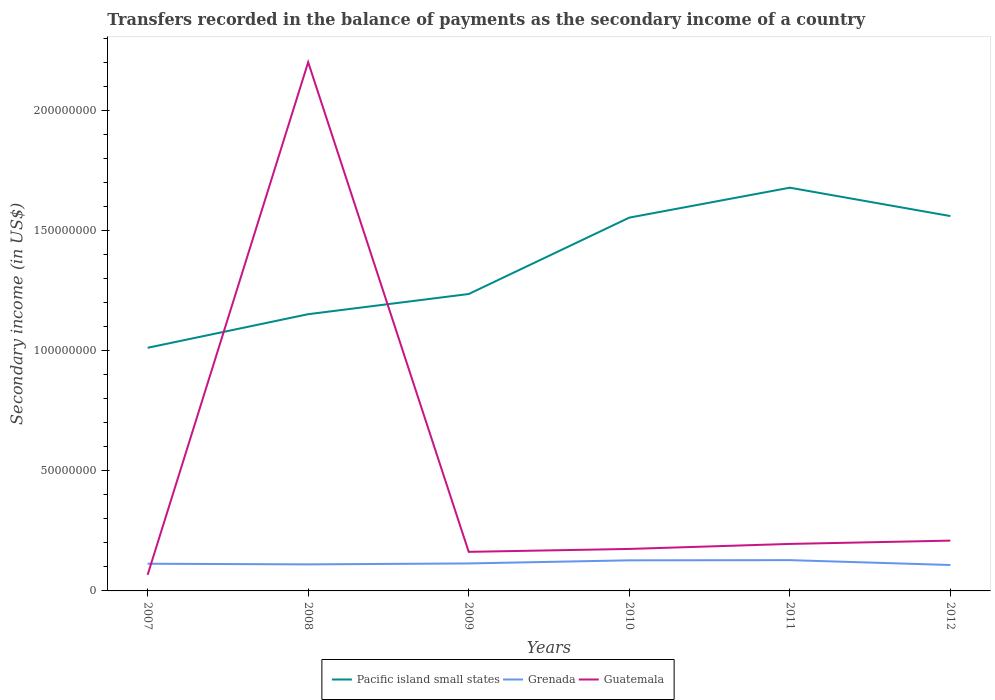How many different coloured lines are there?
Your answer should be very brief. 3. Does the line corresponding to Guatemala intersect with the line corresponding to Grenada?
Give a very brief answer. Yes. Is the number of lines equal to the number of legend labels?
Your response must be concise. Yes. Across all years, what is the maximum secondary income of in Guatemala?
Your answer should be very brief. 6.70e+06. In which year was the secondary income of in Guatemala maximum?
Your response must be concise. 2007. What is the total secondary income of in Guatemala in the graph?
Provide a short and direct response. -3.30e+06. What is the difference between the highest and the second highest secondary income of in Pacific island small states?
Your response must be concise. 6.67e+07. Is the secondary income of in Guatemala strictly greater than the secondary income of in Grenada over the years?
Ensure brevity in your answer.  No. How many lines are there?
Give a very brief answer. 3. What is the difference between two consecutive major ticks on the Y-axis?
Your answer should be compact. 5.00e+07. Are the values on the major ticks of Y-axis written in scientific E-notation?
Provide a short and direct response. No. Does the graph contain grids?
Your response must be concise. No. How many legend labels are there?
Your answer should be very brief. 3. How are the legend labels stacked?
Offer a very short reply. Horizontal. What is the title of the graph?
Your answer should be compact. Transfers recorded in the balance of payments as the secondary income of a country. Does "Indonesia" appear as one of the legend labels in the graph?
Give a very brief answer. No. What is the label or title of the X-axis?
Provide a succinct answer. Years. What is the label or title of the Y-axis?
Ensure brevity in your answer.  Secondary income (in US$). What is the Secondary income (in US$) of Pacific island small states in 2007?
Make the answer very short. 1.01e+08. What is the Secondary income (in US$) in Grenada in 2007?
Ensure brevity in your answer.  1.13e+07. What is the Secondary income (in US$) of Guatemala in 2007?
Offer a terse response. 6.70e+06. What is the Secondary income (in US$) in Pacific island small states in 2008?
Ensure brevity in your answer.  1.15e+08. What is the Secondary income (in US$) of Grenada in 2008?
Offer a terse response. 1.11e+07. What is the Secondary income (in US$) of Guatemala in 2008?
Give a very brief answer. 2.20e+08. What is the Secondary income (in US$) in Pacific island small states in 2009?
Make the answer very short. 1.24e+08. What is the Secondary income (in US$) in Grenada in 2009?
Your response must be concise. 1.14e+07. What is the Secondary income (in US$) in Guatemala in 2009?
Your answer should be very brief. 1.63e+07. What is the Secondary income (in US$) in Pacific island small states in 2010?
Provide a short and direct response. 1.55e+08. What is the Secondary income (in US$) in Grenada in 2010?
Give a very brief answer. 1.27e+07. What is the Secondary income (in US$) in Guatemala in 2010?
Provide a short and direct response. 1.75e+07. What is the Secondary income (in US$) of Pacific island small states in 2011?
Offer a very short reply. 1.68e+08. What is the Secondary income (in US$) in Grenada in 2011?
Provide a short and direct response. 1.28e+07. What is the Secondary income (in US$) in Guatemala in 2011?
Offer a terse response. 1.96e+07. What is the Secondary income (in US$) of Pacific island small states in 2012?
Provide a short and direct response. 1.56e+08. What is the Secondary income (in US$) in Grenada in 2012?
Keep it short and to the point. 1.08e+07. What is the Secondary income (in US$) of Guatemala in 2012?
Make the answer very short. 2.09e+07. Across all years, what is the maximum Secondary income (in US$) of Pacific island small states?
Offer a very short reply. 1.68e+08. Across all years, what is the maximum Secondary income (in US$) of Grenada?
Give a very brief answer. 1.28e+07. Across all years, what is the maximum Secondary income (in US$) in Guatemala?
Your answer should be compact. 2.20e+08. Across all years, what is the minimum Secondary income (in US$) in Pacific island small states?
Provide a succinct answer. 1.01e+08. Across all years, what is the minimum Secondary income (in US$) in Grenada?
Provide a short and direct response. 1.08e+07. Across all years, what is the minimum Secondary income (in US$) of Guatemala?
Provide a succinct answer. 6.70e+06. What is the total Secondary income (in US$) in Pacific island small states in the graph?
Your response must be concise. 8.19e+08. What is the total Secondary income (in US$) in Grenada in the graph?
Keep it short and to the point. 7.01e+07. What is the total Secondary income (in US$) of Guatemala in the graph?
Offer a very short reply. 3.01e+08. What is the difference between the Secondary income (in US$) in Pacific island small states in 2007 and that in 2008?
Ensure brevity in your answer.  -1.40e+07. What is the difference between the Secondary income (in US$) of Grenada in 2007 and that in 2008?
Your response must be concise. 2.65e+05. What is the difference between the Secondary income (in US$) of Guatemala in 2007 and that in 2008?
Your response must be concise. -2.13e+08. What is the difference between the Secondary income (in US$) in Pacific island small states in 2007 and that in 2009?
Provide a short and direct response. -2.24e+07. What is the difference between the Secondary income (in US$) in Grenada in 2007 and that in 2009?
Provide a short and direct response. -1.26e+05. What is the difference between the Secondary income (in US$) in Guatemala in 2007 and that in 2009?
Your answer should be very brief. -9.56e+06. What is the difference between the Secondary income (in US$) in Pacific island small states in 2007 and that in 2010?
Ensure brevity in your answer.  -5.42e+07. What is the difference between the Secondary income (in US$) of Grenada in 2007 and that in 2010?
Provide a succinct answer. -1.42e+06. What is the difference between the Secondary income (in US$) of Guatemala in 2007 and that in 2010?
Your answer should be compact. -1.08e+07. What is the difference between the Secondary income (in US$) in Pacific island small states in 2007 and that in 2011?
Offer a very short reply. -6.67e+07. What is the difference between the Secondary income (in US$) in Grenada in 2007 and that in 2011?
Your answer should be compact. -1.49e+06. What is the difference between the Secondary income (in US$) in Guatemala in 2007 and that in 2011?
Your answer should be very brief. -1.29e+07. What is the difference between the Secondary income (in US$) of Pacific island small states in 2007 and that in 2012?
Give a very brief answer. -5.48e+07. What is the difference between the Secondary income (in US$) in Grenada in 2007 and that in 2012?
Provide a short and direct response. 5.26e+05. What is the difference between the Secondary income (in US$) of Guatemala in 2007 and that in 2012?
Ensure brevity in your answer.  -1.42e+07. What is the difference between the Secondary income (in US$) in Pacific island small states in 2008 and that in 2009?
Provide a short and direct response. -8.40e+06. What is the difference between the Secondary income (in US$) of Grenada in 2008 and that in 2009?
Keep it short and to the point. -3.91e+05. What is the difference between the Secondary income (in US$) of Guatemala in 2008 and that in 2009?
Your answer should be very brief. 2.04e+08. What is the difference between the Secondary income (in US$) in Pacific island small states in 2008 and that in 2010?
Your answer should be compact. -4.02e+07. What is the difference between the Secondary income (in US$) in Grenada in 2008 and that in 2010?
Your answer should be compact. -1.68e+06. What is the difference between the Secondary income (in US$) of Guatemala in 2008 and that in 2010?
Provide a short and direct response. 2.03e+08. What is the difference between the Secondary income (in US$) in Pacific island small states in 2008 and that in 2011?
Make the answer very short. -5.27e+07. What is the difference between the Secondary income (in US$) in Grenada in 2008 and that in 2011?
Ensure brevity in your answer.  -1.76e+06. What is the difference between the Secondary income (in US$) of Guatemala in 2008 and that in 2011?
Offer a very short reply. 2.01e+08. What is the difference between the Secondary income (in US$) in Pacific island small states in 2008 and that in 2012?
Make the answer very short. -4.08e+07. What is the difference between the Secondary income (in US$) of Grenada in 2008 and that in 2012?
Provide a succinct answer. 2.61e+05. What is the difference between the Secondary income (in US$) in Guatemala in 2008 and that in 2012?
Ensure brevity in your answer.  1.99e+08. What is the difference between the Secondary income (in US$) of Pacific island small states in 2009 and that in 2010?
Keep it short and to the point. -3.18e+07. What is the difference between the Secondary income (in US$) of Grenada in 2009 and that in 2010?
Your answer should be very brief. -1.29e+06. What is the difference between the Secondary income (in US$) in Guatemala in 2009 and that in 2010?
Offer a very short reply. -1.21e+06. What is the difference between the Secondary income (in US$) in Pacific island small states in 2009 and that in 2011?
Offer a terse response. -4.43e+07. What is the difference between the Secondary income (in US$) in Grenada in 2009 and that in 2011?
Ensure brevity in your answer.  -1.37e+06. What is the difference between the Secondary income (in US$) of Guatemala in 2009 and that in 2011?
Provide a succinct answer. -3.30e+06. What is the difference between the Secondary income (in US$) of Pacific island small states in 2009 and that in 2012?
Ensure brevity in your answer.  -3.24e+07. What is the difference between the Secondary income (in US$) in Grenada in 2009 and that in 2012?
Ensure brevity in your answer.  6.51e+05. What is the difference between the Secondary income (in US$) of Guatemala in 2009 and that in 2012?
Make the answer very short. -4.67e+06. What is the difference between the Secondary income (in US$) of Pacific island small states in 2010 and that in 2011?
Offer a very short reply. -1.25e+07. What is the difference between the Secondary income (in US$) of Grenada in 2010 and that in 2011?
Provide a succinct answer. -7.81e+04. What is the difference between the Secondary income (in US$) of Guatemala in 2010 and that in 2011?
Provide a short and direct response. -2.09e+06. What is the difference between the Secondary income (in US$) in Pacific island small states in 2010 and that in 2012?
Provide a succinct answer. -6.51e+05. What is the difference between the Secondary income (in US$) in Grenada in 2010 and that in 2012?
Offer a terse response. 1.94e+06. What is the difference between the Secondary income (in US$) in Guatemala in 2010 and that in 2012?
Provide a succinct answer. -3.46e+06. What is the difference between the Secondary income (in US$) in Pacific island small states in 2011 and that in 2012?
Ensure brevity in your answer.  1.18e+07. What is the difference between the Secondary income (in US$) in Grenada in 2011 and that in 2012?
Provide a short and direct response. 2.02e+06. What is the difference between the Secondary income (in US$) in Guatemala in 2011 and that in 2012?
Your response must be concise. -1.37e+06. What is the difference between the Secondary income (in US$) in Pacific island small states in 2007 and the Secondary income (in US$) in Grenada in 2008?
Your answer should be very brief. 9.02e+07. What is the difference between the Secondary income (in US$) in Pacific island small states in 2007 and the Secondary income (in US$) in Guatemala in 2008?
Provide a succinct answer. -1.19e+08. What is the difference between the Secondary income (in US$) of Grenada in 2007 and the Secondary income (in US$) of Guatemala in 2008?
Your response must be concise. -2.09e+08. What is the difference between the Secondary income (in US$) in Pacific island small states in 2007 and the Secondary income (in US$) in Grenada in 2009?
Keep it short and to the point. 8.98e+07. What is the difference between the Secondary income (in US$) in Pacific island small states in 2007 and the Secondary income (in US$) in Guatemala in 2009?
Your answer should be very brief. 8.49e+07. What is the difference between the Secondary income (in US$) of Grenada in 2007 and the Secondary income (in US$) of Guatemala in 2009?
Give a very brief answer. -4.95e+06. What is the difference between the Secondary income (in US$) of Pacific island small states in 2007 and the Secondary income (in US$) of Grenada in 2010?
Offer a terse response. 8.85e+07. What is the difference between the Secondary income (in US$) of Pacific island small states in 2007 and the Secondary income (in US$) of Guatemala in 2010?
Keep it short and to the point. 8.37e+07. What is the difference between the Secondary income (in US$) in Grenada in 2007 and the Secondary income (in US$) in Guatemala in 2010?
Your answer should be very brief. -6.16e+06. What is the difference between the Secondary income (in US$) of Pacific island small states in 2007 and the Secondary income (in US$) of Grenada in 2011?
Make the answer very short. 8.84e+07. What is the difference between the Secondary income (in US$) in Pacific island small states in 2007 and the Secondary income (in US$) in Guatemala in 2011?
Keep it short and to the point. 8.16e+07. What is the difference between the Secondary income (in US$) of Grenada in 2007 and the Secondary income (in US$) of Guatemala in 2011?
Provide a short and direct response. -8.25e+06. What is the difference between the Secondary income (in US$) of Pacific island small states in 2007 and the Secondary income (in US$) of Grenada in 2012?
Make the answer very short. 9.04e+07. What is the difference between the Secondary income (in US$) of Pacific island small states in 2007 and the Secondary income (in US$) of Guatemala in 2012?
Keep it short and to the point. 8.03e+07. What is the difference between the Secondary income (in US$) of Grenada in 2007 and the Secondary income (in US$) of Guatemala in 2012?
Ensure brevity in your answer.  -9.62e+06. What is the difference between the Secondary income (in US$) in Pacific island small states in 2008 and the Secondary income (in US$) in Grenada in 2009?
Your response must be concise. 1.04e+08. What is the difference between the Secondary income (in US$) of Pacific island small states in 2008 and the Secondary income (in US$) of Guatemala in 2009?
Your answer should be compact. 9.89e+07. What is the difference between the Secondary income (in US$) of Grenada in 2008 and the Secondary income (in US$) of Guatemala in 2009?
Keep it short and to the point. -5.21e+06. What is the difference between the Secondary income (in US$) of Pacific island small states in 2008 and the Secondary income (in US$) of Grenada in 2010?
Your response must be concise. 1.02e+08. What is the difference between the Secondary income (in US$) in Pacific island small states in 2008 and the Secondary income (in US$) in Guatemala in 2010?
Your response must be concise. 9.77e+07. What is the difference between the Secondary income (in US$) of Grenada in 2008 and the Secondary income (in US$) of Guatemala in 2010?
Your answer should be very brief. -6.43e+06. What is the difference between the Secondary income (in US$) of Pacific island small states in 2008 and the Secondary income (in US$) of Grenada in 2011?
Offer a terse response. 1.02e+08. What is the difference between the Secondary income (in US$) in Pacific island small states in 2008 and the Secondary income (in US$) in Guatemala in 2011?
Ensure brevity in your answer.  9.56e+07. What is the difference between the Secondary income (in US$) in Grenada in 2008 and the Secondary income (in US$) in Guatemala in 2011?
Keep it short and to the point. -8.51e+06. What is the difference between the Secondary income (in US$) of Pacific island small states in 2008 and the Secondary income (in US$) of Grenada in 2012?
Offer a very short reply. 1.04e+08. What is the difference between the Secondary income (in US$) in Pacific island small states in 2008 and the Secondary income (in US$) in Guatemala in 2012?
Ensure brevity in your answer.  9.43e+07. What is the difference between the Secondary income (in US$) of Grenada in 2008 and the Secondary income (in US$) of Guatemala in 2012?
Make the answer very short. -9.89e+06. What is the difference between the Secondary income (in US$) of Pacific island small states in 2009 and the Secondary income (in US$) of Grenada in 2010?
Offer a terse response. 1.11e+08. What is the difference between the Secondary income (in US$) of Pacific island small states in 2009 and the Secondary income (in US$) of Guatemala in 2010?
Your answer should be compact. 1.06e+08. What is the difference between the Secondary income (in US$) of Grenada in 2009 and the Secondary income (in US$) of Guatemala in 2010?
Make the answer very short. -6.03e+06. What is the difference between the Secondary income (in US$) of Pacific island small states in 2009 and the Secondary income (in US$) of Grenada in 2011?
Provide a succinct answer. 1.11e+08. What is the difference between the Secondary income (in US$) in Pacific island small states in 2009 and the Secondary income (in US$) in Guatemala in 2011?
Ensure brevity in your answer.  1.04e+08. What is the difference between the Secondary income (in US$) in Grenada in 2009 and the Secondary income (in US$) in Guatemala in 2011?
Make the answer very short. -8.12e+06. What is the difference between the Secondary income (in US$) in Pacific island small states in 2009 and the Secondary income (in US$) in Grenada in 2012?
Provide a short and direct response. 1.13e+08. What is the difference between the Secondary income (in US$) in Pacific island small states in 2009 and the Secondary income (in US$) in Guatemala in 2012?
Offer a terse response. 1.03e+08. What is the difference between the Secondary income (in US$) of Grenada in 2009 and the Secondary income (in US$) of Guatemala in 2012?
Your answer should be very brief. -9.49e+06. What is the difference between the Secondary income (in US$) in Pacific island small states in 2010 and the Secondary income (in US$) in Grenada in 2011?
Offer a terse response. 1.43e+08. What is the difference between the Secondary income (in US$) of Pacific island small states in 2010 and the Secondary income (in US$) of Guatemala in 2011?
Offer a very short reply. 1.36e+08. What is the difference between the Secondary income (in US$) of Grenada in 2010 and the Secondary income (in US$) of Guatemala in 2011?
Give a very brief answer. -6.83e+06. What is the difference between the Secondary income (in US$) of Pacific island small states in 2010 and the Secondary income (in US$) of Grenada in 2012?
Offer a very short reply. 1.45e+08. What is the difference between the Secondary income (in US$) of Pacific island small states in 2010 and the Secondary income (in US$) of Guatemala in 2012?
Give a very brief answer. 1.34e+08. What is the difference between the Secondary income (in US$) of Grenada in 2010 and the Secondary income (in US$) of Guatemala in 2012?
Give a very brief answer. -8.20e+06. What is the difference between the Secondary income (in US$) of Pacific island small states in 2011 and the Secondary income (in US$) of Grenada in 2012?
Offer a terse response. 1.57e+08. What is the difference between the Secondary income (in US$) of Pacific island small states in 2011 and the Secondary income (in US$) of Guatemala in 2012?
Your answer should be compact. 1.47e+08. What is the difference between the Secondary income (in US$) in Grenada in 2011 and the Secondary income (in US$) in Guatemala in 2012?
Your answer should be compact. -8.13e+06. What is the average Secondary income (in US$) in Pacific island small states per year?
Your response must be concise. 1.37e+08. What is the average Secondary income (in US$) of Grenada per year?
Offer a terse response. 1.17e+07. What is the average Secondary income (in US$) of Guatemala per year?
Offer a terse response. 5.02e+07. In the year 2007, what is the difference between the Secondary income (in US$) in Pacific island small states and Secondary income (in US$) in Grenada?
Provide a short and direct response. 8.99e+07. In the year 2007, what is the difference between the Secondary income (in US$) in Pacific island small states and Secondary income (in US$) in Guatemala?
Offer a very short reply. 9.45e+07. In the year 2007, what is the difference between the Secondary income (in US$) of Grenada and Secondary income (in US$) of Guatemala?
Offer a very short reply. 4.62e+06. In the year 2008, what is the difference between the Secondary income (in US$) of Pacific island small states and Secondary income (in US$) of Grenada?
Keep it short and to the point. 1.04e+08. In the year 2008, what is the difference between the Secondary income (in US$) of Pacific island small states and Secondary income (in US$) of Guatemala?
Give a very brief answer. -1.05e+08. In the year 2008, what is the difference between the Secondary income (in US$) in Grenada and Secondary income (in US$) in Guatemala?
Offer a terse response. -2.09e+08. In the year 2009, what is the difference between the Secondary income (in US$) in Pacific island small states and Secondary income (in US$) in Grenada?
Offer a terse response. 1.12e+08. In the year 2009, what is the difference between the Secondary income (in US$) of Pacific island small states and Secondary income (in US$) of Guatemala?
Provide a short and direct response. 1.07e+08. In the year 2009, what is the difference between the Secondary income (in US$) in Grenada and Secondary income (in US$) in Guatemala?
Provide a short and direct response. -4.82e+06. In the year 2010, what is the difference between the Secondary income (in US$) of Pacific island small states and Secondary income (in US$) of Grenada?
Offer a very short reply. 1.43e+08. In the year 2010, what is the difference between the Secondary income (in US$) in Pacific island small states and Secondary income (in US$) in Guatemala?
Give a very brief answer. 1.38e+08. In the year 2010, what is the difference between the Secondary income (in US$) of Grenada and Secondary income (in US$) of Guatemala?
Your answer should be very brief. -4.74e+06. In the year 2011, what is the difference between the Secondary income (in US$) of Pacific island small states and Secondary income (in US$) of Grenada?
Offer a very short reply. 1.55e+08. In the year 2011, what is the difference between the Secondary income (in US$) of Pacific island small states and Secondary income (in US$) of Guatemala?
Your answer should be very brief. 1.48e+08. In the year 2011, what is the difference between the Secondary income (in US$) in Grenada and Secondary income (in US$) in Guatemala?
Your response must be concise. -6.75e+06. In the year 2012, what is the difference between the Secondary income (in US$) of Pacific island small states and Secondary income (in US$) of Grenada?
Your answer should be compact. 1.45e+08. In the year 2012, what is the difference between the Secondary income (in US$) in Pacific island small states and Secondary income (in US$) in Guatemala?
Make the answer very short. 1.35e+08. In the year 2012, what is the difference between the Secondary income (in US$) in Grenada and Secondary income (in US$) in Guatemala?
Offer a terse response. -1.01e+07. What is the ratio of the Secondary income (in US$) in Pacific island small states in 2007 to that in 2008?
Keep it short and to the point. 0.88. What is the ratio of the Secondary income (in US$) of Guatemala in 2007 to that in 2008?
Provide a short and direct response. 0.03. What is the ratio of the Secondary income (in US$) in Pacific island small states in 2007 to that in 2009?
Provide a short and direct response. 0.82. What is the ratio of the Secondary income (in US$) of Grenada in 2007 to that in 2009?
Ensure brevity in your answer.  0.99. What is the ratio of the Secondary income (in US$) in Guatemala in 2007 to that in 2009?
Your answer should be very brief. 0.41. What is the ratio of the Secondary income (in US$) in Pacific island small states in 2007 to that in 2010?
Offer a very short reply. 0.65. What is the ratio of the Secondary income (in US$) of Grenada in 2007 to that in 2010?
Ensure brevity in your answer.  0.89. What is the ratio of the Secondary income (in US$) of Guatemala in 2007 to that in 2010?
Make the answer very short. 0.38. What is the ratio of the Secondary income (in US$) of Pacific island small states in 2007 to that in 2011?
Ensure brevity in your answer.  0.6. What is the ratio of the Secondary income (in US$) in Grenada in 2007 to that in 2011?
Provide a short and direct response. 0.88. What is the ratio of the Secondary income (in US$) in Guatemala in 2007 to that in 2011?
Your answer should be very brief. 0.34. What is the ratio of the Secondary income (in US$) of Pacific island small states in 2007 to that in 2012?
Make the answer very short. 0.65. What is the ratio of the Secondary income (in US$) of Grenada in 2007 to that in 2012?
Keep it short and to the point. 1.05. What is the ratio of the Secondary income (in US$) in Guatemala in 2007 to that in 2012?
Make the answer very short. 0.32. What is the ratio of the Secondary income (in US$) of Pacific island small states in 2008 to that in 2009?
Provide a succinct answer. 0.93. What is the ratio of the Secondary income (in US$) in Grenada in 2008 to that in 2009?
Give a very brief answer. 0.97. What is the ratio of the Secondary income (in US$) of Guatemala in 2008 to that in 2009?
Ensure brevity in your answer.  13.53. What is the ratio of the Secondary income (in US$) in Pacific island small states in 2008 to that in 2010?
Make the answer very short. 0.74. What is the ratio of the Secondary income (in US$) in Grenada in 2008 to that in 2010?
Your answer should be compact. 0.87. What is the ratio of the Secondary income (in US$) in Guatemala in 2008 to that in 2010?
Keep it short and to the point. 12.59. What is the ratio of the Secondary income (in US$) of Pacific island small states in 2008 to that in 2011?
Provide a short and direct response. 0.69. What is the ratio of the Secondary income (in US$) in Grenada in 2008 to that in 2011?
Offer a terse response. 0.86. What is the ratio of the Secondary income (in US$) of Guatemala in 2008 to that in 2011?
Provide a succinct answer. 11.25. What is the ratio of the Secondary income (in US$) in Pacific island small states in 2008 to that in 2012?
Your answer should be compact. 0.74. What is the ratio of the Secondary income (in US$) of Grenada in 2008 to that in 2012?
Provide a short and direct response. 1.02. What is the ratio of the Secondary income (in US$) of Guatemala in 2008 to that in 2012?
Provide a short and direct response. 10.51. What is the ratio of the Secondary income (in US$) of Pacific island small states in 2009 to that in 2010?
Give a very brief answer. 0.8. What is the ratio of the Secondary income (in US$) of Grenada in 2009 to that in 2010?
Your answer should be very brief. 0.9. What is the ratio of the Secondary income (in US$) in Guatemala in 2009 to that in 2010?
Your answer should be very brief. 0.93. What is the ratio of the Secondary income (in US$) in Pacific island small states in 2009 to that in 2011?
Offer a terse response. 0.74. What is the ratio of the Secondary income (in US$) of Grenada in 2009 to that in 2011?
Give a very brief answer. 0.89. What is the ratio of the Secondary income (in US$) in Guatemala in 2009 to that in 2011?
Provide a succinct answer. 0.83. What is the ratio of the Secondary income (in US$) of Pacific island small states in 2009 to that in 2012?
Your response must be concise. 0.79. What is the ratio of the Secondary income (in US$) in Grenada in 2009 to that in 2012?
Your response must be concise. 1.06. What is the ratio of the Secondary income (in US$) of Guatemala in 2009 to that in 2012?
Make the answer very short. 0.78. What is the ratio of the Secondary income (in US$) in Pacific island small states in 2010 to that in 2011?
Give a very brief answer. 0.93. What is the ratio of the Secondary income (in US$) in Guatemala in 2010 to that in 2011?
Your answer should be compact. 0.89. What is the ratio of the Secondary income (in US$) of Pacific island small states in 2010 to that in 2012?
Give a very brief answer. 1. What is the ratio of the Secondary income (in US$) of Grenada in 2010 to that in 2012?
Provide a short and direct response. 1.18. What is the ratio of the Secondary income (in US$) in Guatemala in 2010 to that in 2012?
Make the answer very short. 0.83. What is the ratio of the Secondary income (in US$) of Pacific island small states in 2011 to that in 2012?
Make the answer very short. 1.08. What is the ratio of the Secondary income (in US$) of Grenada in 2011 to that in 2012?
Keep it short and to the point. 1.19. What is the ratio of the Secondary income (in US$) of Guatemala in 2011 to that in 2012?
Provide a succinct answer. 0.93. What is the difference between the highest and the second highest Secondary income (in US$) of Pacific island small states?
Your answer should be compact. 1.18e+07. What is the difference between the highest and the second highest Secondary income (in US$) of Grenada?
Provide a succinct answer. 7.81e+04. What is the difference between the highest and the second highest Secondary income (in US$) of Guatemala?
Make the answer very short. 1.99e+08. What is the difference between the highest and the lowest Secondary income (in US$) in Pacific island small states?
Give a very brief answer. 6.67e+07. What is the difference between the highest and the lowest Secondary income (in US$) of Grenada?
Your answer should be compact. 2.02e+06. What is the difference between the highest and the lowest Secondary income (in US$) in Guatemala?
Give a very brief answer. 2.13e+08. 